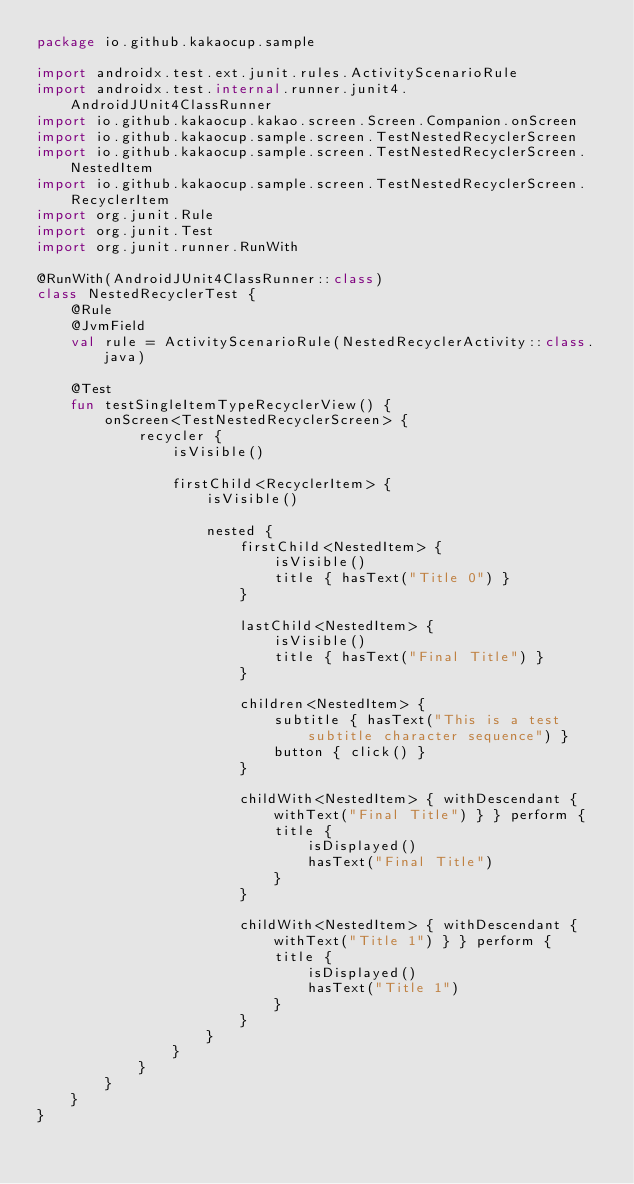<code> <loc_0><loc_0><loc_500><loc_500><_Kotlin_>package io.github.kakaocup.sample

import androidx.test.ext.junit.rules.ActivityScenarioRule
import androidx.test.internal.runner.junit4.AndroidJUnit4ClassRunner
import io.github.kakaocup.kakao.screen.Screen.Companion.onScreen
import io.github.kakaocup.sample.screen.TestNestedRecyclerScreen
import io.github.kakaocup.sample.screen.TestNestedRecyclerScreen.NestedItem
import io.github.kakaocup.sample.screen.TestNestedRecyclerScreen.RecyclerItem
import org.junit.Rule
import org.junit.Test
import org.junit.runner.RunWith

@RunWith(AndroidJUnit4ClassRunner::class)
class NestedRecyclerTest {
    @Rule
    @JvmField
    val rule = ActivityScenarioRule(NestedRecyclerActivity::class.java)

    @Test
    fun testSingleItemTypeRecyclerView() {
        onScreen<TestNestedRecyclerScreen> {
            recycler {
                isVisible()

                firstChild<RecyclerItem> {
                    isVisible()

                    nested {
                        firstChild<NestedItem> {
                            isVisible()
                            title { hasText("Title 0") }
                        }

                        lastChild<NestedItem> {
                            isVisible()
                            title { hasText("Final Title") }
                        }

                        children<NestedItem> {
                            subtitle { hasText("This is a test subtitle character sequence") }
                            button { click() }
                        }

                        childWith<NestedItem> { withDescendant { withText("Final Title") } } perform {
                            title {
                                isDisplayed()
                                hasText("Final Title")
                            }
                        }

                        childWith<NestedItem> { withDescendant { withText("Title 1") } } perform {
                            title {
                                isDisplayed()
                                hasText("Title 1")
                            }
                        }
                    }
                }
            }
        }
    }
}
</code> 